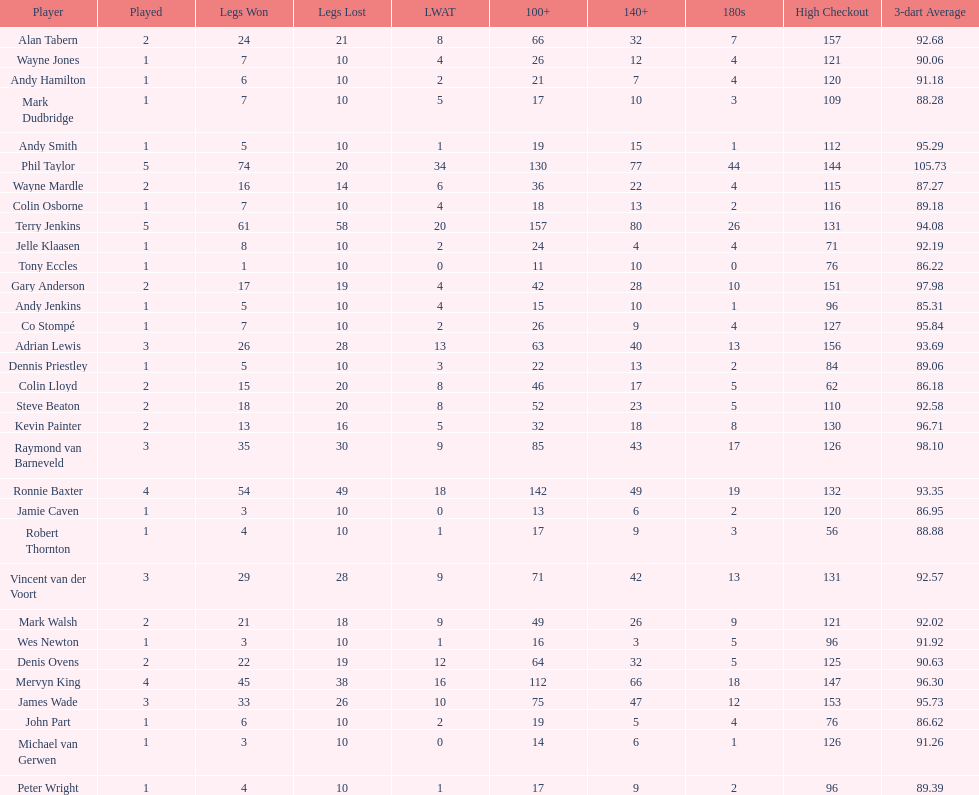What were the total number of legs won by ronnie baxter? 54. 